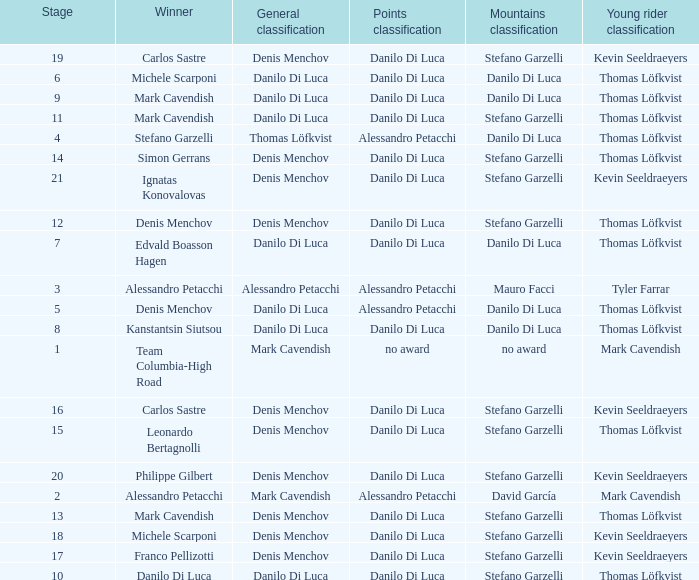When 19 is the stage who is the points classification? Danilo Di Luca. 